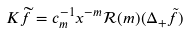Convert formula to latex. <formula><loc_0><loc_0><loc_500><loc_500>K \widetilde { f } = c _ { m } ^ { - 1 } x ^ { - m } \mathcal { R } ( m ) ( \Delta _ { + } \tilde { f } )</formula> 